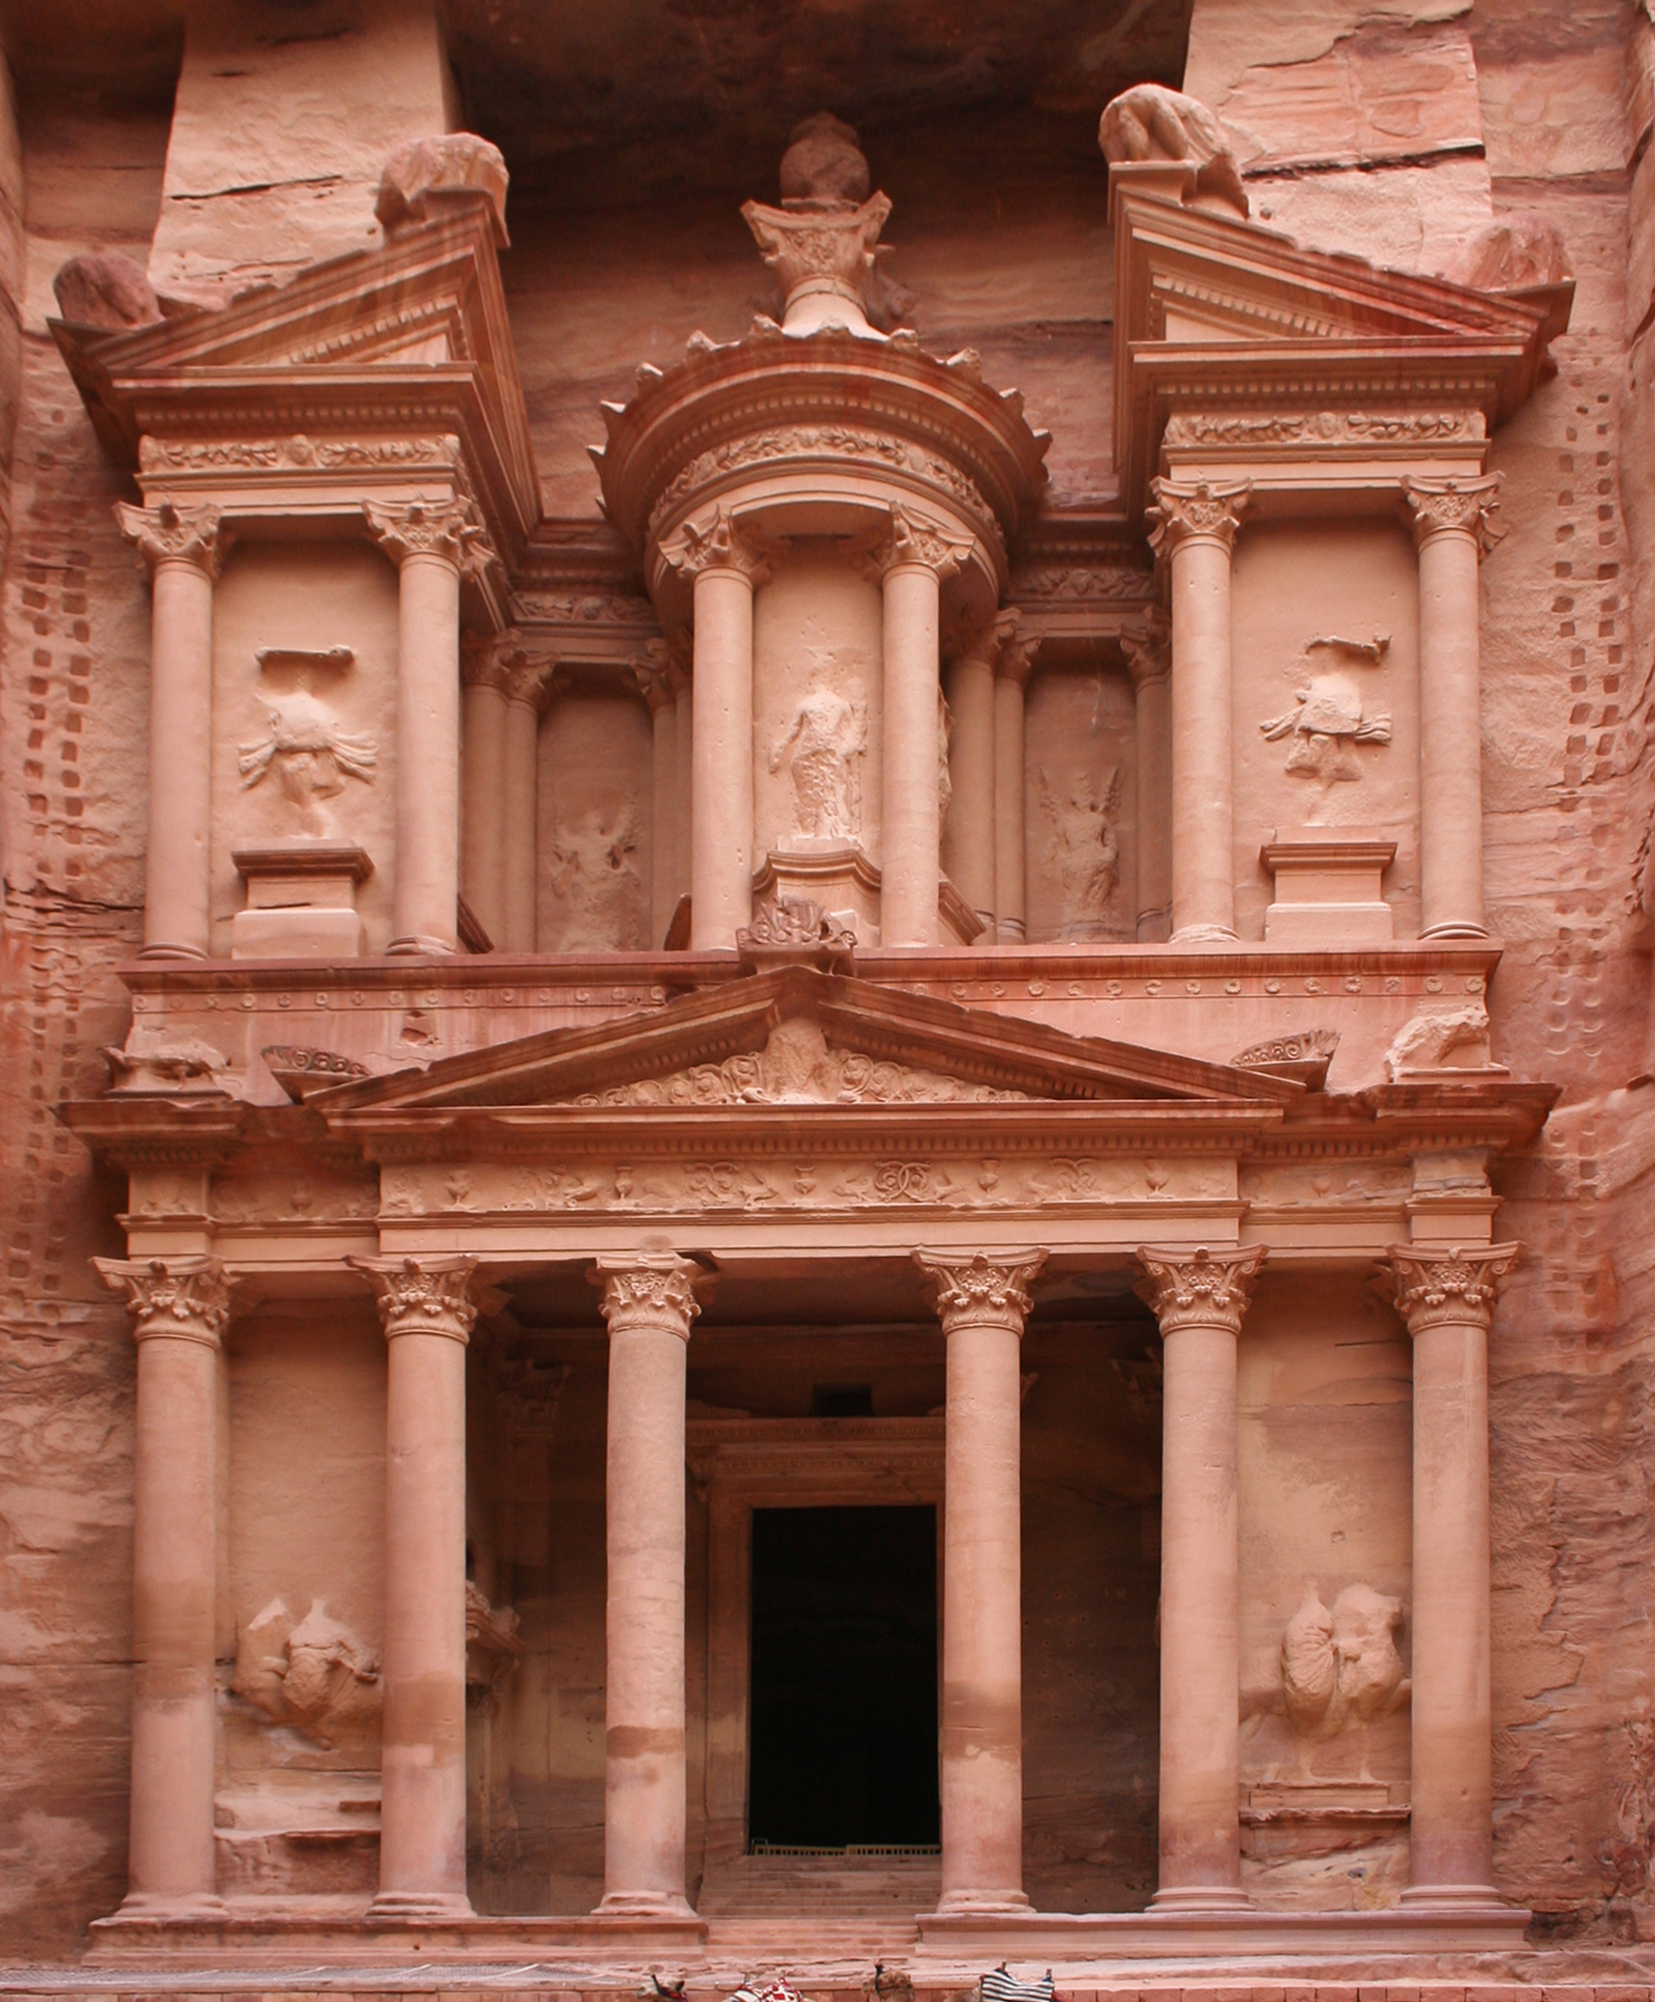How has the preservation of Al-Khazneh been approached in modern times? Modern preservation efforts for Al-Khazneh involve careful management by both Jordanian authorities and international organizations. These efforts include monitoring the structural integrity, controlling visitor access to reduce wear, and conducting detailed studies to understand the effects of environmental factors on the sandstone. The aim is to maintain the physical and visual integrity of this ancient marvel for future generations. 